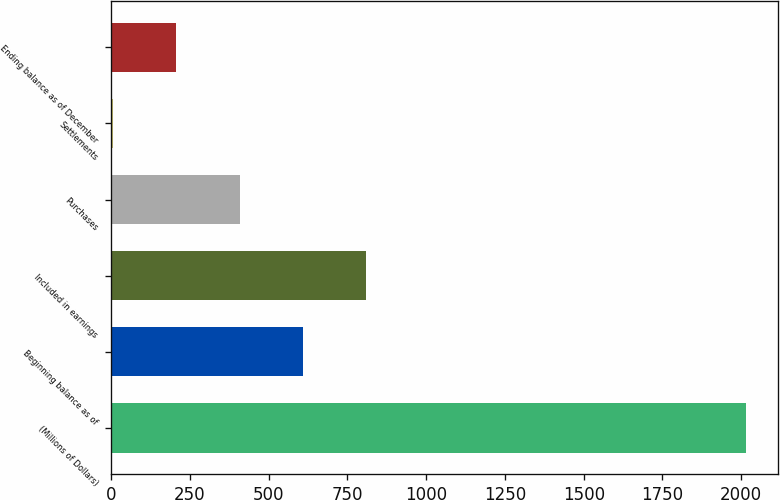<chart> <loc_0><loc_0><loc_500><loc_500><bar_chart><fcel>(Millions of Dollars)<fcel>Beginning balance as of<fcel>Included in earnings<fcel>Purchases<fcel>Settlements<fcel>Ending balance as of December<nl><fcel>2015<fcel>608.7<fcel>809.6<fcel>407.8<fcel>6<fcel>206.9<nl></chart> 